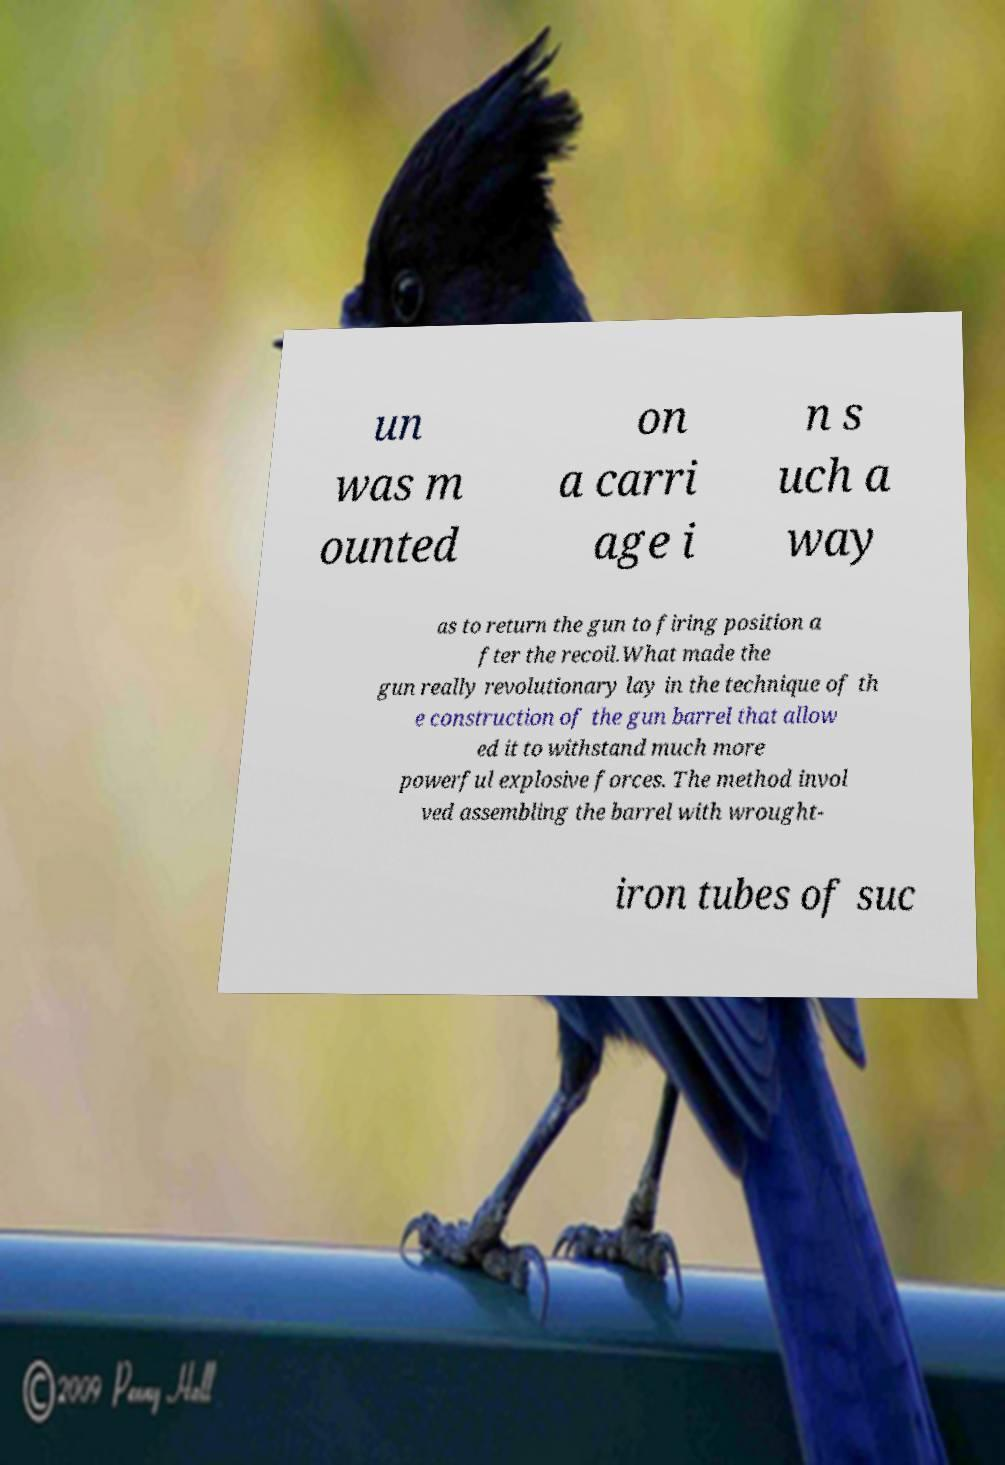Could you extract and type out the text from this image? un was m ounted on a carri age i n s uch a way as to return the gun to firing position a fter the recoil.What made the gun really revolutionary lay in the technique of th e construction of the gun barrel that allow ed it to withstand much more powerful explosive forces. The method invol ved assembling the barrel with wrought- iron tubes of suc 